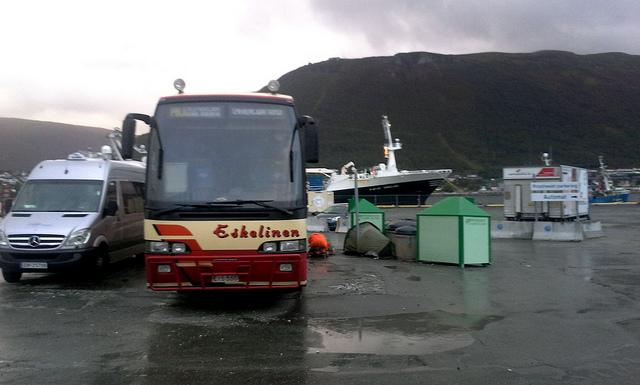What has caused the puddle in front of the bus? rain 